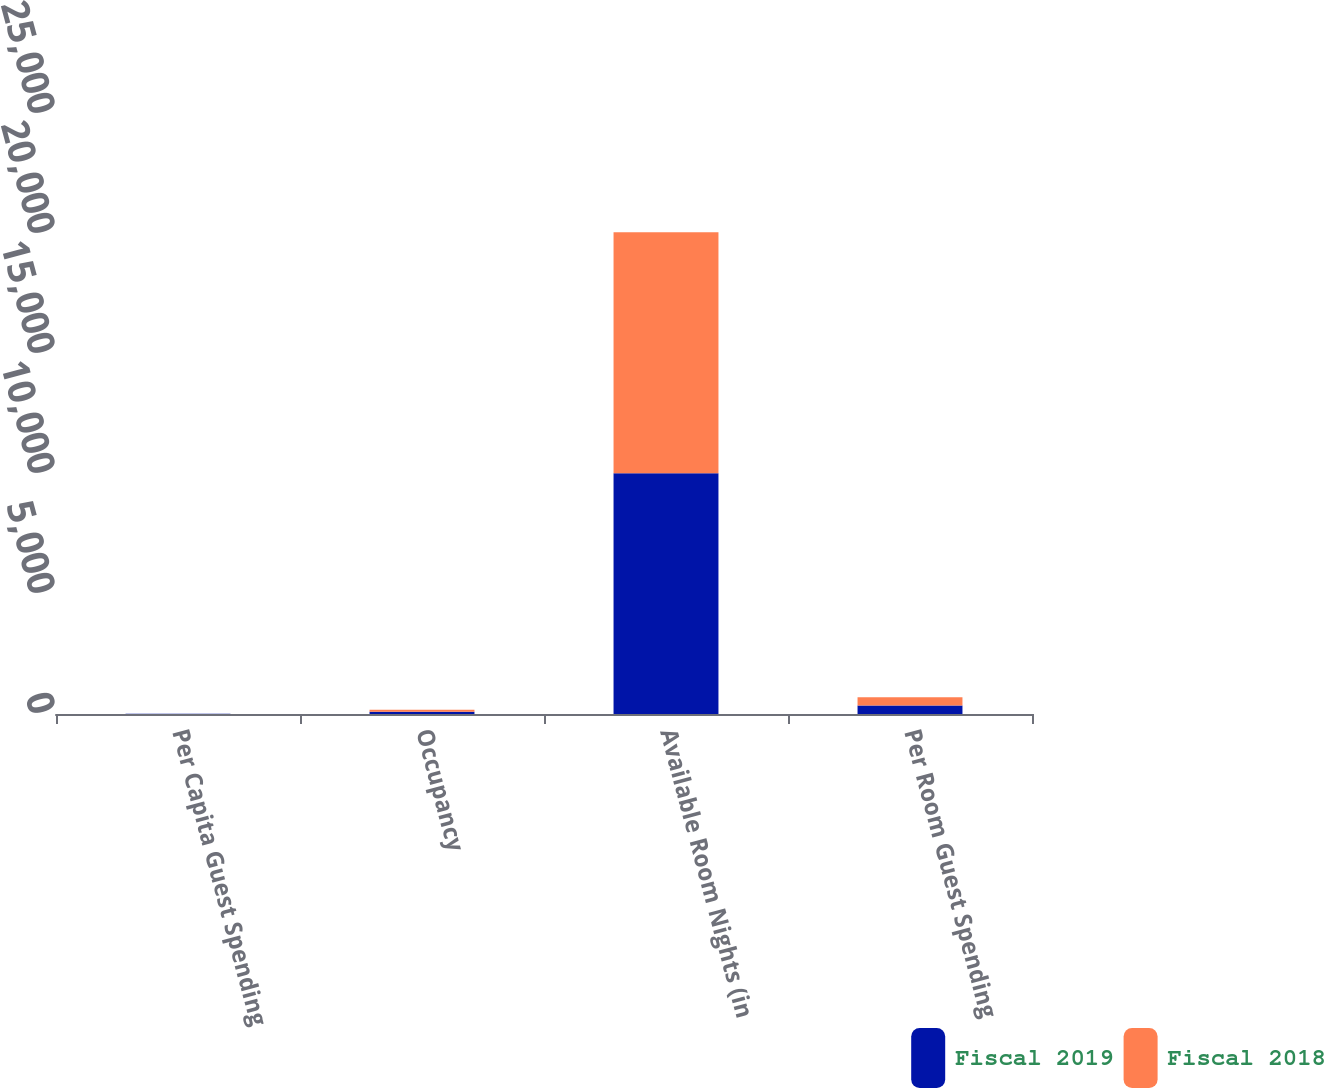Convert chart to OTSL. <chart><loc_0><loc_0><loc_500><loc_500><stacked_bar_chart><ecel><fcel>Per Capita Guest Spending<fcel>Occupancy<fcel>Available Room Nights (in<fcel>Per Room Guest Spending<nl><fcel>Fiscal 2019<fcel>7<fcel>90<fcel>10030<fcel>353<nl><fcel>Fiscal 2018<fcel>6<fcel>88<fcel>10045<fcel>345<nl></chart> 